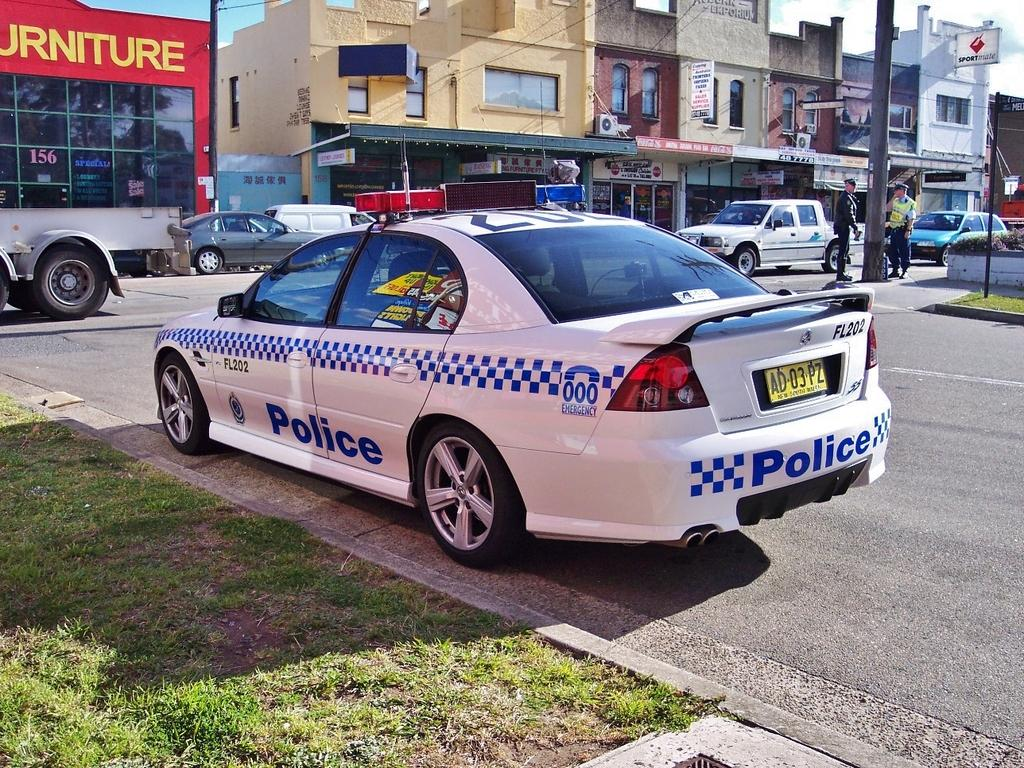What types of structures can be seen in the image? There are buildings in the image. What can be found inside the buildings? There are stores in the image. What are some objects visible in the image? There are vehicles, poles, boards, and a signboard in the image. How many people are standing on the road? Two people are standing on the road. What is the color of the sky in the image? The sky is blue and white in color. What is the number of toys visible in the image? There are no toys present in the image. In what year was the image taken? The provided facts do not include information about the year the image was taken. 